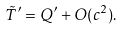<formula> <loc_0><loc_0><loc_500><loc_500>\tilde { T } ^ { \prime } = Q ^ { \prime } + O ( c ^ { 2 } ) .</formula> 